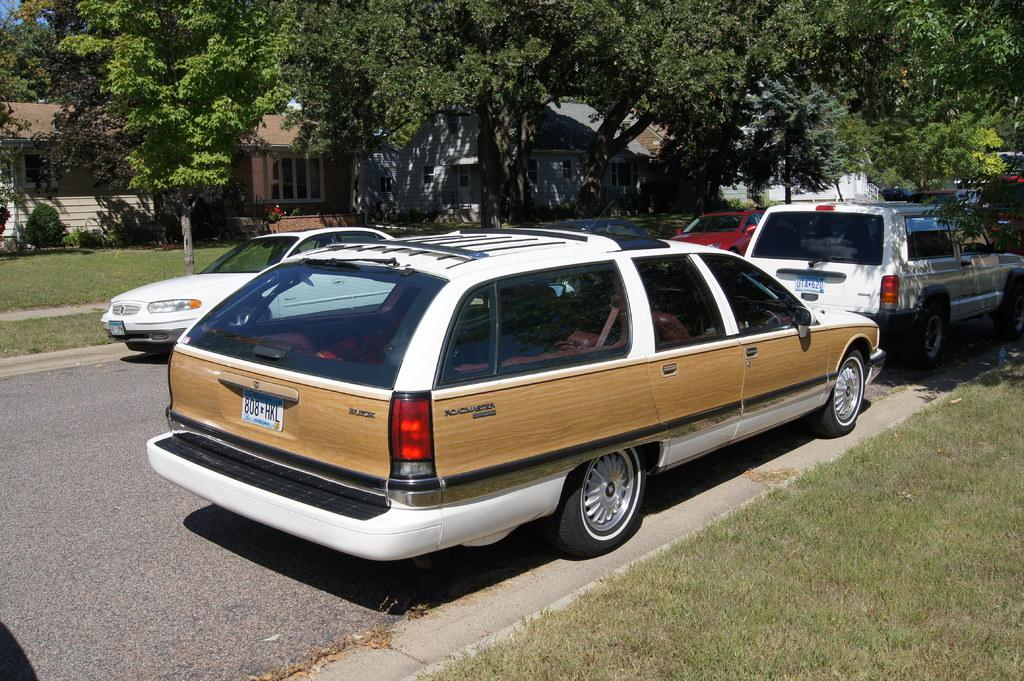Provide a one-sentence caption for the provided image. white station wagon with woodgrain siding and plates 808 HKL. 